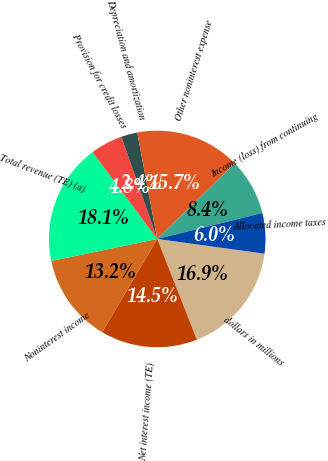Convert chart to OTSL. <chart><loc_0><loc_0><loc_500><loc_500><pie_chart><fcel>dollars in millions<fcel>Net interest income (TE)<fcel>Noninterest income<fcel>Total revenue (TE) (a)<fcel>Provision for credit losses<fcel>Depreciation and amortization<fcel>Other noninterest expense<fcel>Income (loss) from continuing<fcel>Allocated income taxes<nl><fcel>16.86%<fcel>14.46%<fcel>13.25%<fcel>18.07%<fcel>4.82%<fcel>2.42%<fcel>15.66%<fcel>8.44%<fcel>6.03%<nl></chart> 